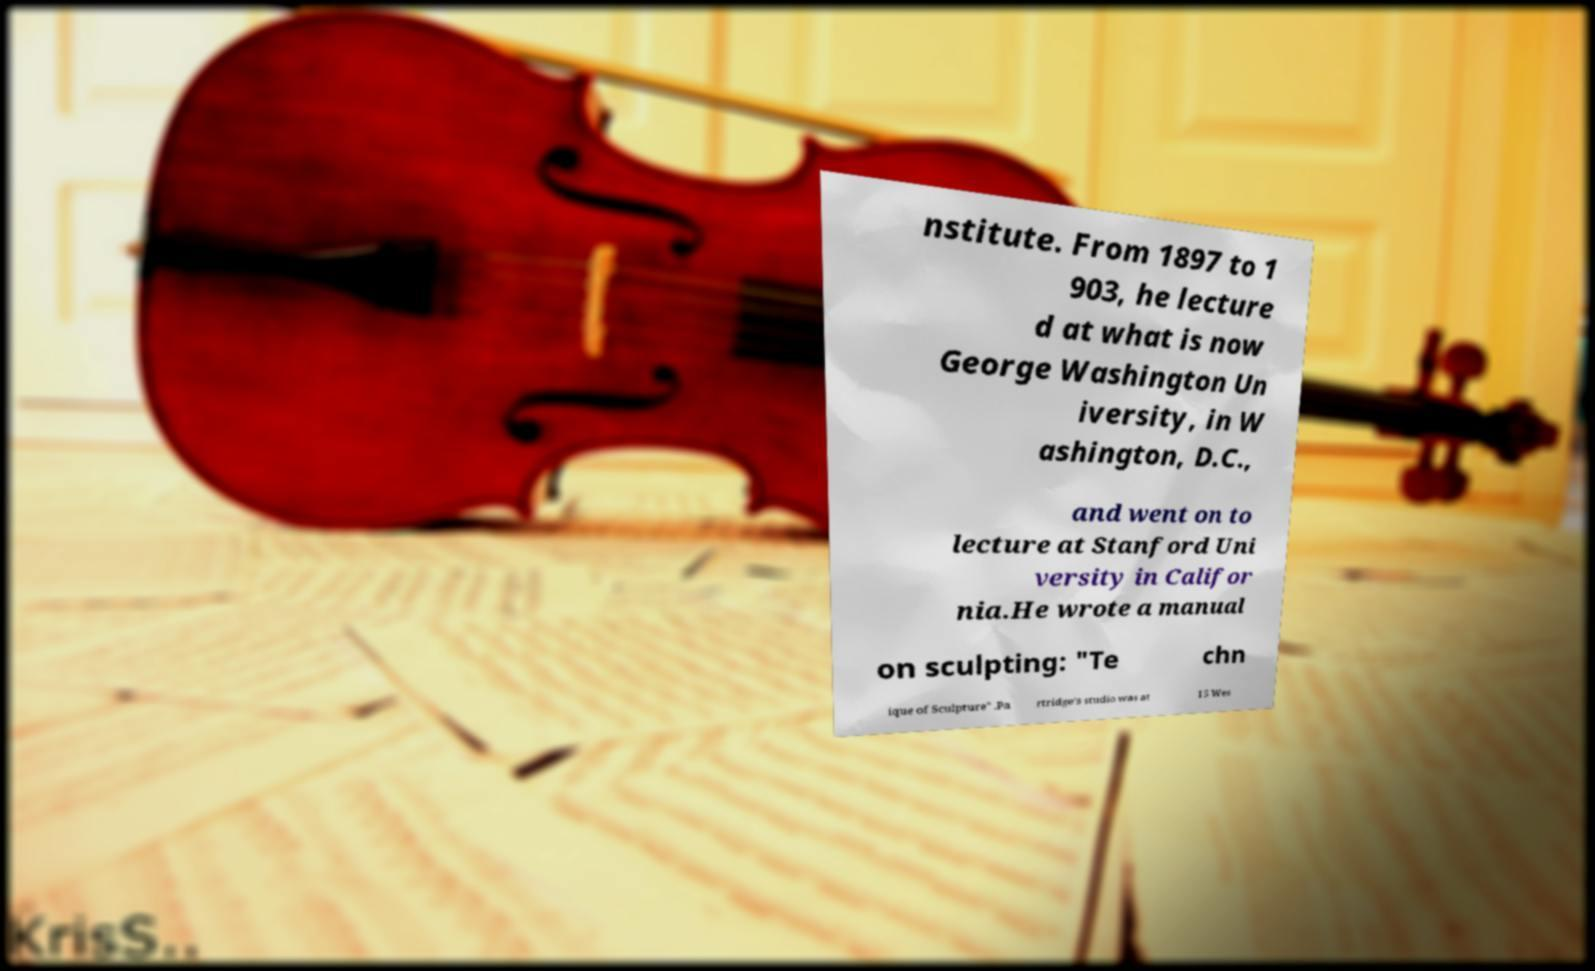Could you extract and type out the text from this image? nstitute. From 1897 to 1 903, he lecture d at what is now George Washington Un iversity, in W ashington, D.C., and went on to lecture at Stanford Uni versity in Califor nia.He wrote a manual on sculpting: "Te chn ique of Sculpture" .Pa rtridge's studio was at 15 Wes 